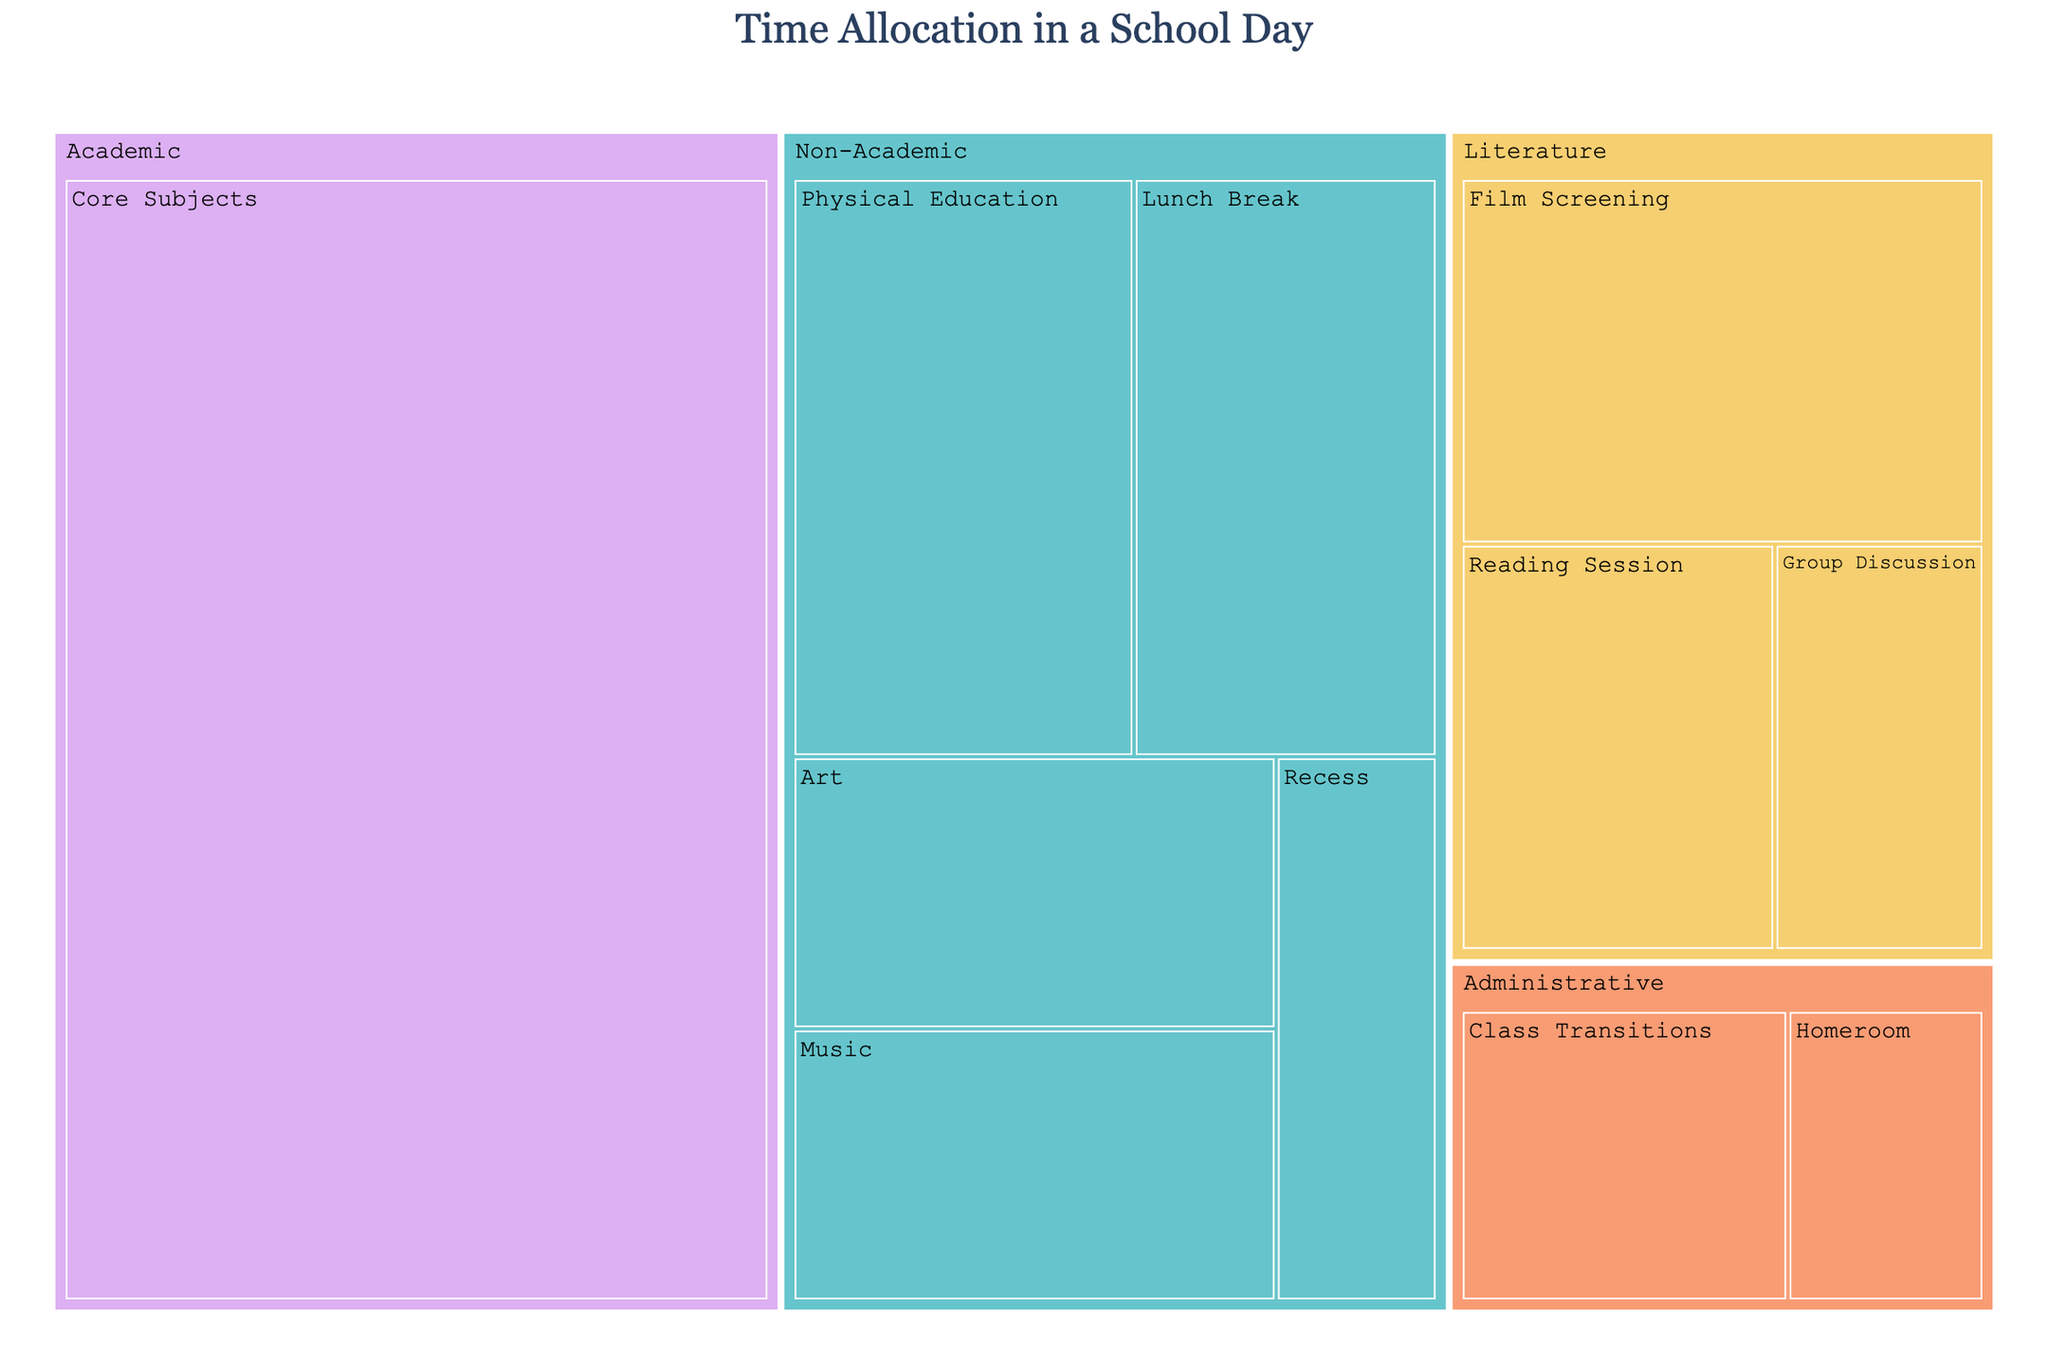Which activity allocates the most time? Look at the size of each block, the largest one represents the activity with the most time allocation.
Answer: Core Subjects Which categories are included in the treemap? The categories are represented by different colored sections, each containing their respective activities.
Answer: Academic, Literature, Non-Academic, Administrative What is the total time allocated for Literature activities? Add up the time for Film Screening (45), Reading Session (30), and Group Discussion (20).
Answer: 95 minutes How does the time for Physical Education compare to Film Screening? Compare the sizes of the blocks for Physical Education and Film Screening.
Answer: Both are 45 minutes Which has more time allocated: Art or Music? Compare the sizes of the blocks for Art and Music.
Answer: Both are 30 minutes What is the percentage of time spent on Administrative activities in the school day? Add the time for Administrative activities (Homeroom: 15, Class Transitions: 25) and divide by the total time of all activities, then multiply by 100. (15+25)/480 * 100%.
Answer: 8.3% Calculate the combined time for Non-Academic activities. Sum the time of Physical Education (45), Lunch Break (40), Recess (20), Art (30), Music (30).
Answer: 165 minutes Is there more time allocated to Academic activities or Non-Academic activities? Compare the total time of Core Subjects (180) with the sum of Non-Academic activities (165).
Answer: Academic What activity in the Literature category takes the least time? Identify the smallest block within the Literature category section.
Answer: Group Discussion 